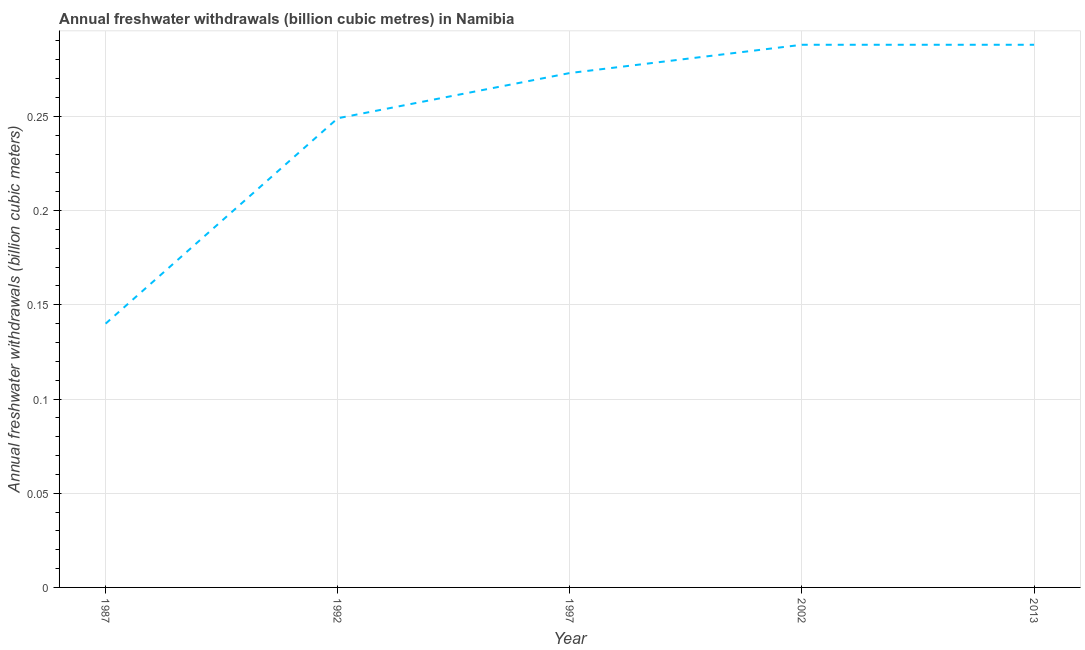What is the annual freshwater withdrawals in 2013?
Provide a short and direct response. 0.29. Across all years, what is the maximum annual freshwater withdrawals?
Keep it short and to the point. 0.29. Across all years, what is the minimum annual freshwater withdrawals?
Your answer should be compact. 0.14. In which year was the annual freshwater withdrawals minimum?
Your response must be concise. 1987. What is the sum of the annual freshwater withdrawals?
Ensure brevity in your answer.  1.24. What is the difference between the annual freshwater withdrawals in 1987 and 2013?
Provide a succinct answer. -0.15. What is the average annual freshwater withdrawals per year?
Provide a succinct answer. 0.25. What is the median annual freshwater withdrawals?
Your answer should be compact. 0.27. What is the ratio of the annual freshwater withdrawals in 1997 to that in 2002?
Offer a very short reply. 0.95. Is the annual freshwater withdrawals in 1987 less than that in 2002?
Offer a very short reply. Yes. Is the difference between the annual freshwater withdrawals in 1992 and 1997 greater than the difference between any two years?
Your answer should be compact. No. What is the difference between the highest and the second highest annual freshwater withdrawals?
Your answer should be compact. 0. What is the difference between the highest and the lowest annual freshwater withdrawals?
Give a very brief answer. 0.15. In how many years, is the annual freshwater withdrawals greater than the average annual freshwater withdrawals taken over all years?
Provide a succinct answer. 4. Does the graph contain grids?
Provide a succinct answer. Yes. What is the title of the graph?
Keep it short and to the point. Annual freshwater withdrawals (billion cubic metres) in Namibia. What is the label or title of the Y-axis?
Ensure brevity in your answer.  Annual freshwater withdrawals (billion cubic meters). What is the Annual freshwater withdrawals (billion cubic meters) of 1987?
Your answer should be compact. 0.14. What is the Annual freshwater withdrawals (billion cubic meters) of 1992?
Give a very brief answer. 0.25. What is the Annual freshwater withdrawals (billion cubic meters) in 1997?
Your response must be concise. 0.27. What is the Annual freshwater withdrawals (billion cubic meters) in 2002?
Provide a succinct answer. 0.29. What is the Annual freshwater withdrawals (billion cubic meters) of 2013?
Offer a terse response. 0.29. What is the difference between the Annual freshwater withdrawals (billion cubic meters) in 1987 and 1992?
Provide a succinct answer. -0.11. What is the difference between the Annual freshwater withdrawals (billion cubic meters) in 1987 and 1997?
Offer a very short reply. -0.13. What is the difference between the Annual freshwater withdrawals (billion cubic meters) in 1987 and 2002?
Your response must be concise. -0.15. What is the difference between the Annual freshwater withdrawals (billion cubic meters) in 1987 and 2013?
Your answer should be very brief. -0.15. What is the difference between the Annual freshwater withdrawals (billion cubic meters) in 1992 and 1997?
Your answer should be compact. -0.02. What is the difference between the Annual freshwater withdrawals (billion cubic meters) in 1992 and 2002?
Offer a terse response. -0.04. What is the difference between the Annual freshwater withdrawals (billion cubic meters) in 1992 and 2013?
Keep it short and to the point. -0.04. What is the difference between the Annual freshwater withdrawals (billion cubic meters) in 1997 and 2002?
Your answer should be compact. -0.01. What is the difference between the Annual freshwater withdrawals (billion cubic meters) in 1997 and 2013?
Offer a very short reply. -0.01. What is the ratio of the Annual freshwater withdrawals (billion cubic meters) in 1987 to that in 1992?
Your answer should be very brief. 0.56. What is the ratio of the Annual freshwater withdrawals (billion cubic meters) in 1987 to that in 1997?
Provide a short and direct response. 0.51. What is the ratio of the Annual freshwater withdrawals (billion cubic meters) in 1987 to that in 2002?
Your answer should be very brief. 0.49. What is the ratio of the Annual freshwater withdrawals (billion cubic meters) in 1987 to that in 2013?
Ensure brevity in your answer.  0.49. What is the ratio of the Annual freshwater withdrawals (billion cubic meters) in 1992 to that in 1997?
Provide a succinct answer. 0.91. What is the ratio of the Annual freshwater withdrawals (billion cubic meters) in 1992 to that in 2002?
Your answer should be very brief. 0.86. What is the ratio of the Annual freshwater withdrawals (billion cubic meters) in 1992 to that in 2013?
Keep it short and to the point. 0.86. What is the ratio of the Annual freshwater withdrawals (billion cubic meters) in 1997 to that in 2002?
Provide a succinct answer. 0.95. What is the ratio of the Annual freshwater withdrawals (billion cubic meters) in 1997 to that in 2013?
Provide a short and direct response. 0.95. What is the ratio of the Annual freshwater withdrawals (billion cubic meters) in 2002 to that in 2013?
Provide a succinct answer. 1. 